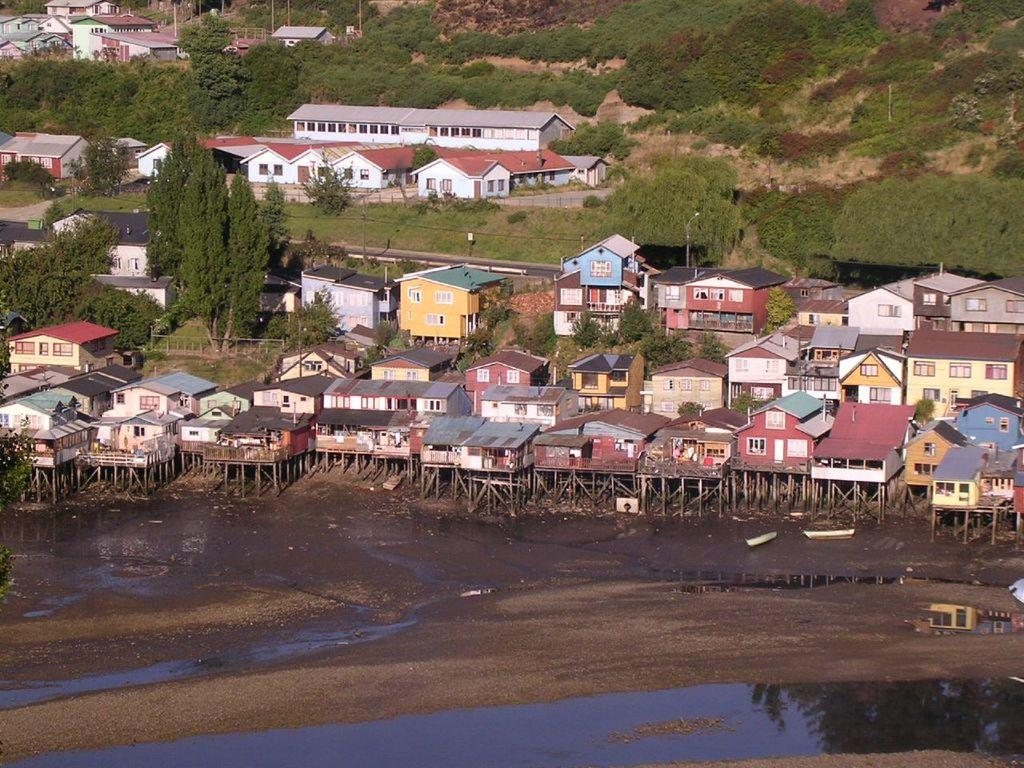What type of structures can be seen in the image? There are buildings in the image. What natural elements are present in the image? There are trees and water visible in the image. What are the poles used for in the image? The purpose of the poles is not specified, but they are likely used for support or signage. What type of vehicles are present in the image? There are boats in the image. What other objects can be seen on the ground in the image? There are other objects on the ground, but their specific nature is not mentioned. What suggestion is being made by the sign in the image? There is no sign present in the image, so no suggestion can be made. What wish is being granted by the magical creature in the image? There is no magical creature present in the image, so no wish can be granted. 